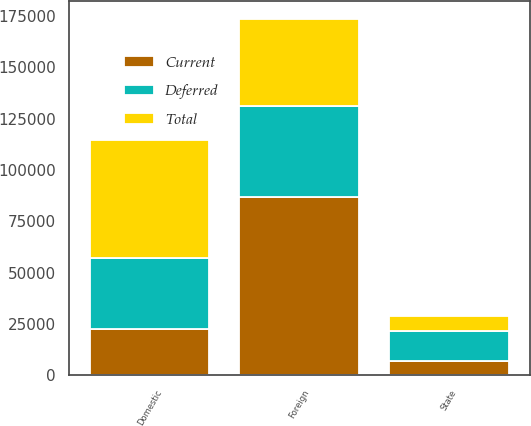Convert chart. <chart><loc_0><loc_0><loc_500><loc_500><stacked_bar_chart><ecel><fcel>Domestic<fcel>Foreign<fcel>State<nl><fcel>Current<fcel>22498<fcel>86880<fcel>7269<nl><fcel>Total<fcel>57378<fcel>42446<fcel>7214<nl><fcel>Deferred<fcel>34880<fcel>44434<fcel>14483<nl></chart> 